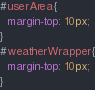Convert code to text. <code><loc_0><loc_0><loc_500><loc_500><_CSS_>#userArea{
  margin-top: 10px;
}
#weatherWrapper{
  margin-top: 10px;
}</code> 